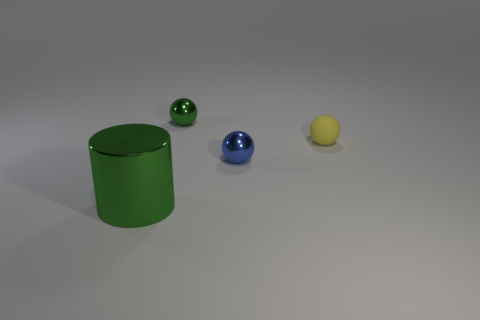Add 4 large metal cylinders. How many objects exist? 8 Subtract all spheres. How many objects are left? 1 Subtract 1 green balls. How many objects are left? 3 Subtract all small cyan shiny cubes. Subtract all large things. How many objects are left? 3 Add 3 rubber balls. How many rubber balls are left? 4 Add 3 blue objects. How many blue objects exist? 4 